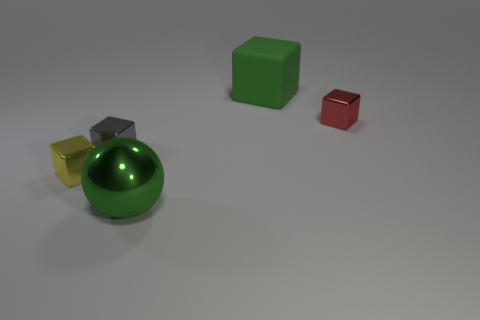Add 1 small yellow objects. How many objects exist? 6 Subtract all cubes. How many objects are left? 1 Add 5 large green metal objects. How many large green metal objects exist? 6 Subtract 0 brown blocks. How many objects are left? 5 Subtract all tiny red metal blocks. Subtract all small metallic objects. How many objects are left? 1 Add 1 big things. How many big things are left? 3 